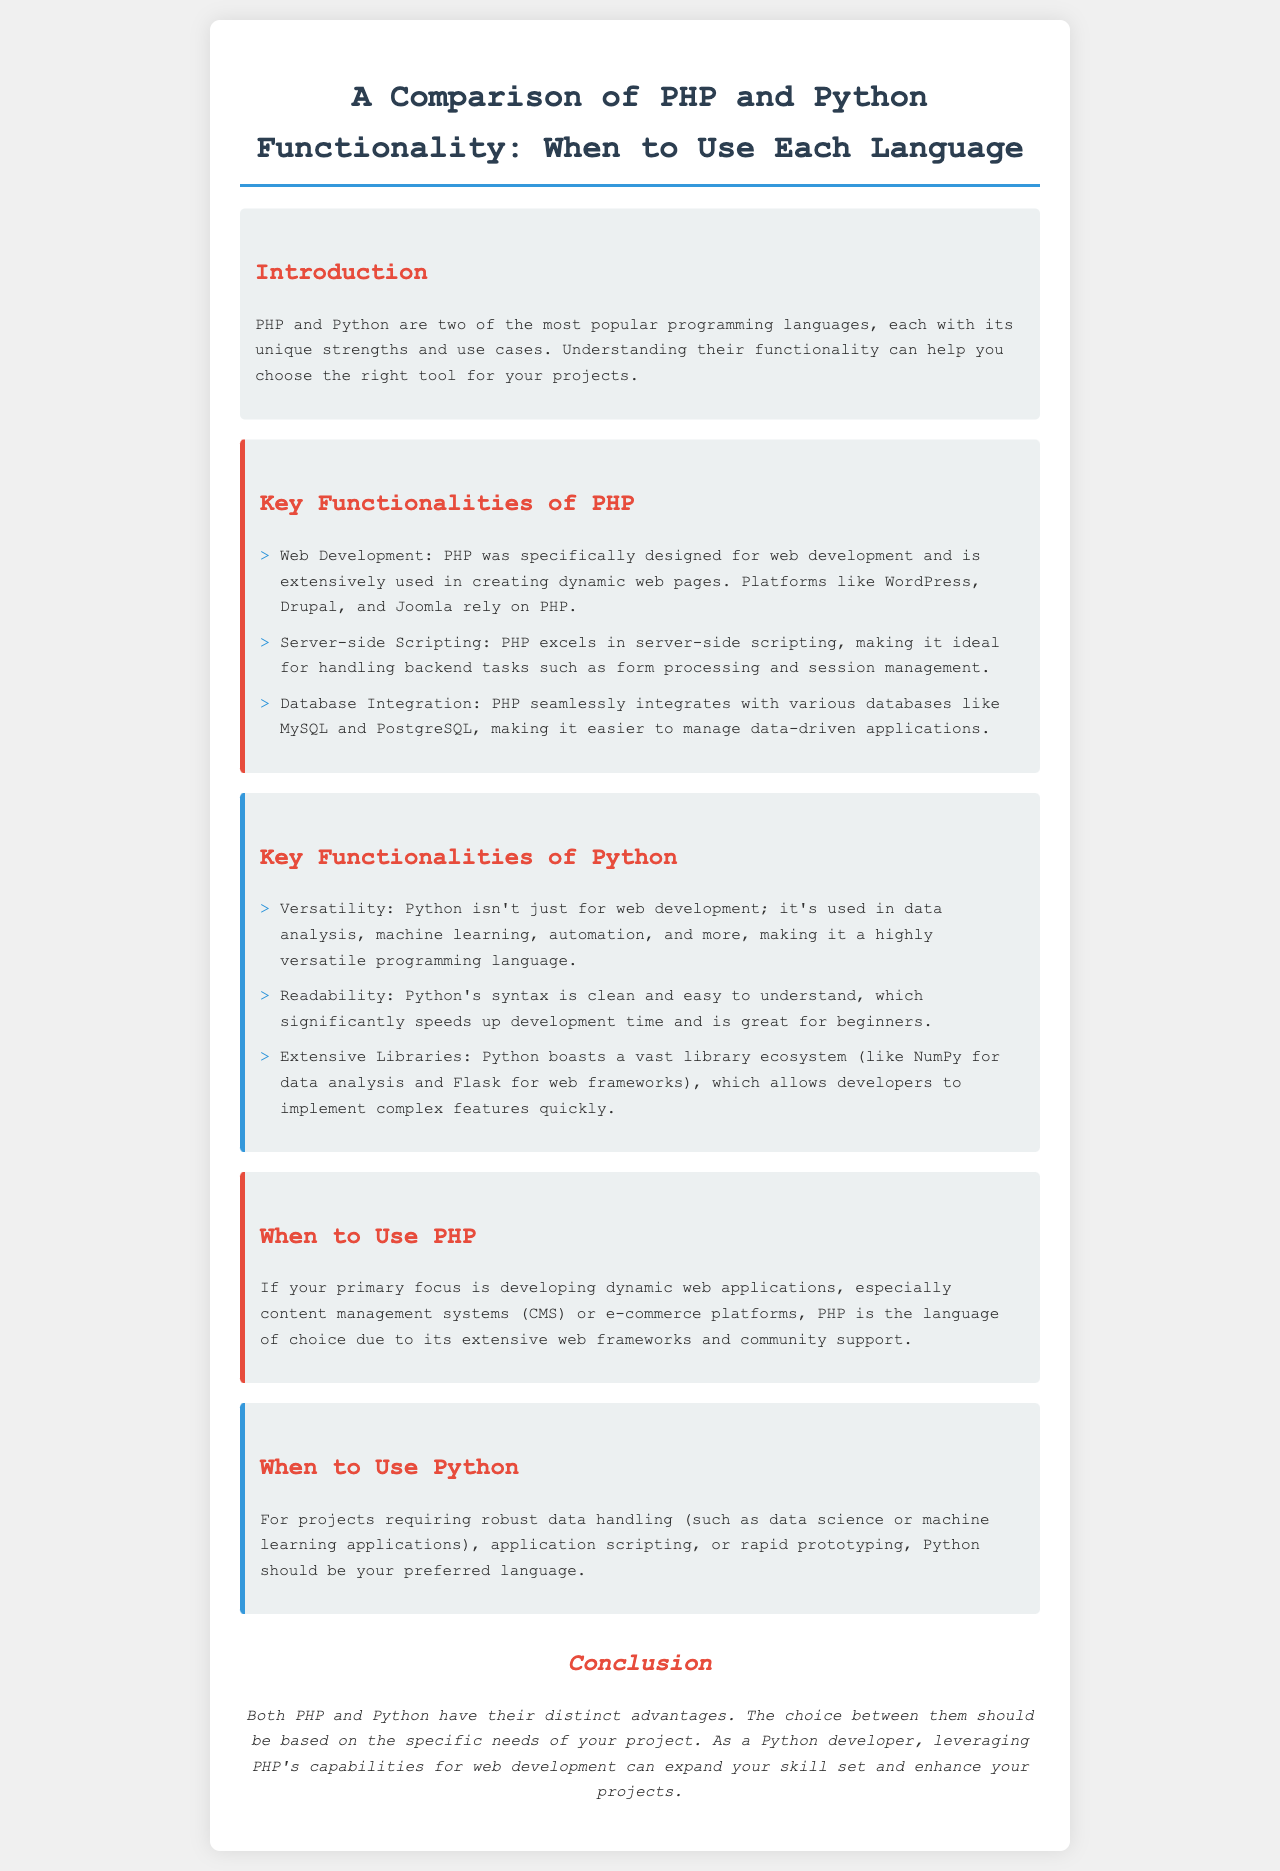What is the main focus of PHP? PHP is primarily designed for developing dynamic web applications, making it suitable for content management systems and e-commerce platforms.
Answer: Web Development What does Python excel in aside from web development? Python is not limited to web development; it is also used in data analysis, machine learning, and automation.
Answer: Versatility Which PHP frameworks are mentioned in the brochure? The brochure mentions platforms that rely on PHP, indicating its use in various frameworks but does not specify any names.
Answer: WordPress, Drupal, Joomla What is a key advantage of Python's syntax? The document highlights that Python's syntax is clean and easy to understand, benefiting development time and beginners.
Answer: Readability When should you consider using PHP? The text specifies to use PHP when focusing on developing dynamic web applications and CMS or e-commerce platforms.
Answer: Dynamic web applications What is highlighted as a crucial aspect of Python libraries? Python has a vast library ecosystem that allows developers to implement complex features quickly, which is a significant advantage.
Answer: Extensive Libraries What is emphasized as the conclusion regarding PHP and Python? The conclusion states that both languages have distinct advantages and the choice should be based on specific project needs.
Answer: Distinct advantages Which language is suggested for robust data handling projects? The brochure suggests using Python for projects that require robust data handling, particularly in data science or machine learning.
Answer: Python 